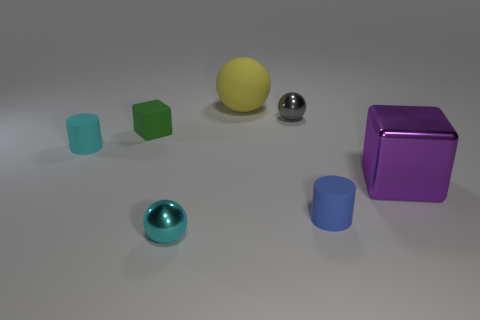Subtract all yellow spheres. How many spheres are left? 2 Add 3 cylinders. How many objects exist? 10 Subtract all purple balls. Subtract all purple blocks. How many balls are left? 3 Add 2 tiny rubber cylinders. How many tiny rubber cylinders exist? 4 Subtract 1 green blocks. How many objects are left? 6 Subtract all cylinders. How many objects are left? 5 Subtract all gray matte cubes. Subtract all small blue cylinders. How many objects are left? 6 Add 2 cyan metal balls. How many cyan metal balls are left? 3 